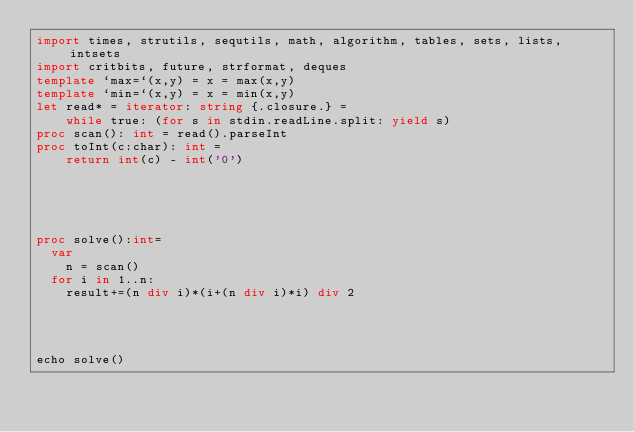Convert code to text. <code><loc_0><loc_0><loc_500><loc_500><_Nim_>import times, strutils, sequtils, math, algorithm, tables, sets, lists, intsets
import critbits, future, strformat, deques
template `max=`(x,y) = x = max(x,y)
template `min=`(x,y) = x = min(x,y)
let read* = iterator: string {.closure.} =
    while true: (for s in stdin.readLine.split: yield s)
proc scan(): int = read().parseInt
proc toInt(c:char): int =
    return int(c) - int('0')





proc solve():int=
  var
    n = scan()
  for i in 1..n:
    result+=(n div i)*(i+(n div i)*i) div 2

  
    
  
echo solve()</code> 